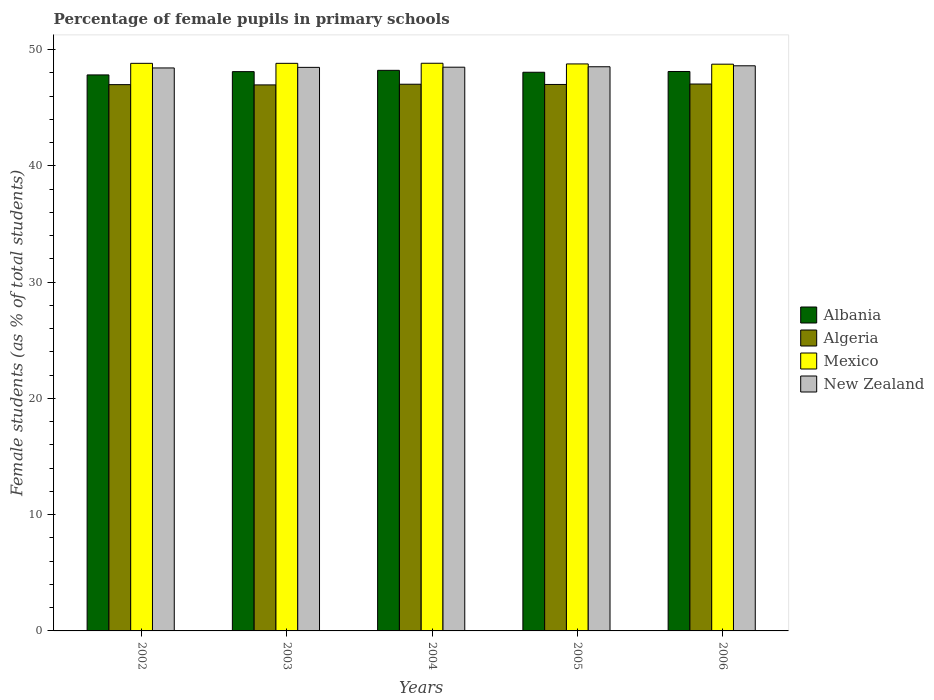How many different coloured bars are there?
Offer a terse response. 4. How many groups of bars are there?
Your answer should be compact. 5. Are the number of bars per tick equal to the number of legend labels?
Offer a very short reply. Yes. How many bars are there on the 4th tick from the left?
Provide a succinct answer. 4. How many bars are there on the 1st tick from the right?
Your answer should be compact. 4. What is the percentage of female pupils in primary schools in Mexico in 2004?
Your answer should be compact. 48.82. Across all years, what is the maximum percentage of female pupils in primary schools in Mexico?
Offer a terse response. 48.82. Across all years, what is the minimum percentage of female pupils in primary schools in New Zealand?
Provide a succinct answer. 48.42. In which year was the percentage of female pupils in primary schools in Algeria maximum?
Keep it short and to the point. 2006. What is the total percentage of female pupils in primary schools in Mexico in the graph?
Offer a very short reply. 243.96. What is the difference between the percentage of female pupils in primary schools in Albania in 2002 and that in 2004?
Ensure brevity in your answer.  -0.39. What is the difference between the percentage of female pupils in primary schools in Mexico in 2005 and the percentage of female pupils in primary schools in New Zealand in 2003?
Provide a short and direct response. 0.3. What is the average percentage of female pupils in primary schools in New Zealand per year?
Your response must be concise. 48.5. In the year 2006, what is the difference between the percentage of female pupils in primary schools in Mexico and percentage of female pupils in primary schools in New Zealand?
Your answer should be very brief. 0.14. What is the ratio of the percentage of female pupils in primary schools in Albania in 2002 to that in 2003?
Provide a succinct answer. 0.99. Is the difference between the percentage of female pupils in primary schools in Mexico in 2002 and 2003 greater than the difference between the percentage of female pupils in primary schools in New Zealand in 2002 and 2003?
Your answer should be very brief. Yes. What is the difference between the highest and the second highest percentage of female pupils in primary schools in Algeria?
Offer a very short reply. 0.02. What is the difference between the highest and the lowest percentage of female pupils in primary schools in Algeria?
Your response must be concise. 0.08. What does the 1st bar from the left in 2005 represents?
Keep it short and to the point. Albania. How many bars are there?
Give a very brief answer. 20. Are the values on the major ticks of Y-axis written in scientific E-notation?
Ensure brevity in your answer.  No. Does the graph contain grids?
Offer a very short reply. No. Where does the legend appear in the graph?
Give a very brief answer. Center right. How many legend labels are there?
Make the answer very short. 4. How are the legend labels stacked?
Provide a short and direct response. Vertical. What is the title of the graph?
Your answer should be compact. Percentage of female pupils in primary schools. What is the label or title of the X-axis?
Offer a very short reply. Years. What is the label or title of the Y-axis?
Keep it short and to the point. Female students (as % of total students). What is the Female students (as % of total students) in Albania in 2002?
Give a very brief answer. 47.82. What is the Female students (as % of total students) in Algeria in 2002?
Your answer should be very brief. 46.98. What is the Female students (as % of total students) of Mexico in 2002?
Make the answer very short. 48.81. What is the Female students (as % of total students) in New Zealand in 2002?
Provide a short and direct response. 48.42. What is the Female students (as % of total students) of Albania in 2003?
Your answer should be very brief. 48.1. What is the Female students (as % of total students) of Algeria in 2003?
Keep it short and to the point. 46.96. What is the Female students (as % of total students) of Mexico in 2003?
Provide a succinct answer. 48.82. What is the Female students (as % of total students) of New Zealand in 2003?
Keep it short and to the point. 48.47. What is the Female students (as % of total students) in Albania in 2004?
Provide a short and direct response. 48.21. What is the Female students (as % of total students) in Algeria in 2004?
Provide a succinct answer. 47.02. What is the Female students (as % of total students) of Mexico in 2004?
Ensure brevity in your answer.  48.82. What is the Female students (as % of total students) in New Zealand in 2004?
Offer a very short reply. 48.48. What is the Female students (as % of total students) in Albania in 2005?
Keep it short and to the point. 48.05. What is the Female students (as % of total students) in Algeria in 2005?
Your answer should be very brief. 47. What is the Female students (as % of total students) of Mexico in 2005?
Your answer should be compact. 48.76. What is the Female students (as % of total students) in New Zealand in 2005?
Your answer should be compact. 48.52. What is the Female students (as % of total students) in Albania in 2006?
Your response must be concise. 48.11. What is the Female students (as % of total students) in Algeria in 2006?
Ensure brevity in your answer.  47.04. What is the Female students (as % of total students) of Mexico in 2006?
Your response must be concise. 48.74. What is the Female students (as % of total students) of New Zealand in 2006?
Give a very brief answer. 48.6. Across all years, what is the maximum Female students (as % of total students) in Albania?
Your answer should be compact. 48.21. Across all years, what is the maximum Female students (as % of total students) in Algeria?
Provide a short and direct response. 47.04. Across all years, what is the maximum Female students (as % of total students) in Mexico?
Your answer should be compact. 48.82. Across all years, what is the maximum Female students (as % of total students) of New Zealand?
Offer a very short reply. 48.6. Across all years, what is the minimum Female students (as % of total students) of Albania?
Give a very brief answer. 47.82. Across all years, what is the minimum Female students (as % of total students) in Algeria?
Make the answer very short. 46.96. Across all years, what is the minimum Female students (as % of total students) in Mexico?
Your answer should be compact. 48.74. Across all years, what is the minimum Female students (as % of total students) of New Zealand?
Ensure brevity in your answer.  48.42. What is the total Female students (as % of total students) in Albania in the graph?
Ensure brevity in your answer.  240.29. What is the total Female students (as % of total students) of Algeria in the graph?
Give a very brief answer. 234.99. What is the total Female students (as % of total students) in Mexico in the graph?
Offer a very short reply. 243.96. What is the total Female students (as % of total students) of New Zealand in the graph?
Offer a very short reply. 242.49. What is the difference between the Female students (as % of total students) of Albania in 2002 and that in 2003?
Give a very brief answer. -0.28. What is the difference between the Female students (as % of total students) of Algeria in 2002 and that in 2003?
Give a very brief answer. 0.02. What is the difference between the Female students (as % of total students) in Mexico in 2002 and that in 2003?
Give a very brief answer. -0. What is the difference between the Female students (as % of total students) in New Zealand in 2002 and that in 2003?
Make the answer very short. -0.05. What is the difference between the Female students (as % of total students) of Albania in 2002 and that in 2004?
Your answer should be compact. -0.39. What is the difference between the Female students (as % of total students) of Algeria in 2002 and that in 2004?
Give a very brief answer. -0.04. What is the difference between the Female students (as % of total students) in Mexico in 2002 and that in 2004?
Keep it short and to the point. -0.01. What is the difference between the Female students (as % of total students) of New Zealand in 2002 and that in 2004?
Ensure brevity in your answer.  -0.06. What is the difference between the Female students (as % of total students) of Albania in 2002 and that in 2005?
Ensure brevity in your answer.  -0.23. What is the difference between the Female students (as % of total students) in Algeria in 2002 and that in 2005?
Offer a terse response. -0.01. What is the difference between the Female students (as % of total students) in Mexico in 2002 and that in 2005?
Provide a succinct answer. 0.05. What is the difference between the Female students (as % of total students) in New Zealand in 2002 and that in 2005?
Give a very brief answer. -0.1. What is the difference between the Female students (as % of total students) of Albania in 2002 and that in 2006?
Your response must be concise. -0.29. What is the difference between the Female students (as % of total students) of Algeria in 2002 and that in 2006?
Offer a terse response. -0.05. What is the difference between the Female students (as % of total students) in Mexico in 2002 and that in 2006?
Provide a short and direct response. 0.07. What is the difference between the Female students (as % of total students) in New Zealand in 2002 and that in 2006?
Make the answer very short. -0.19. What is the difference between the Female students (as % of total students) of Albania in 2003 and that in 2004?
Provide a succinct answer. -0.11. What is the difference between the Female students (as % of total students) in Algeria in 2003 and that in 2004?
Your response must be concise. -0.06. What is the difference between the Female students (as % of total students) in Mexico in 2003 and that in 2004?
Give a very brief answer. -0.01. What is the difference between the Female students (as % of total students) in New Zealand in 2003 and that in 2004?
Your answer should be very brief. -0.01. What is the difference between the Female students (as % of total students) in Albania in 2003 and that in 2005?
Provide a succinct answer. 0.05. What is the difference between the Female students (as % of total students) of Algeria in 2003 and that in 2005?
Offer a very short reply. -0.04. What is the difference between the Female students (as % of total students) in Mexico in 2003 and that in 2005?
Offer a terse response. 0.05. What is the difference between the Female students (as % of total students) of New Zealand in 2003 and that in 2005?
Provide a short and direct response. -0.05. What is the difference between the Female students (as % of total students) of Albania in 2003 and that in 2006?
Keep it short and to the point. -0.01. What is the difference between the Female students (as % of total students) of Algeria in 2003 and that in 2006?
Ensure brevity in your answer.  -0.08. What is the difference between the Female students (as % of total students) in Mexico in 2003 and that in 2006?
Offer a terse response. 0.07. What is the difference between the Female students (as % of total students) in New Zealand in 2003 and that in 2006?
Provide a succinct answer. -0.14. What is the difference between the Female students (as % of total students) in Albania in 2004 and that in 2005?
Your answer should be very brief. 0.17. What is the difference between the Female students (as % of total students) of Algeria in 2004 and that in 2005?
Your answer should be very brief. 0.02. What is the difference between the Female students (as % of total students) of Mexico in 2004 and that in 2005?
Your answer should be very brief. 0.06. What is the difference between the Female students (as % of total students) of New Zealand in 2004 and that in 2005?
Make the answer very short. -0.04. What is the difference between the Female students (as % of total students) in Albania in 2004 and that in 2006?
Make the answer very short. 0.1. What is the difference between the Female students (as % of total students) in Algeria in 2004 and that in 2006?
Your answer should be very brief. -0.02. What is the difference between the Female students (as % of total students) in Mexico in 2004 and that in 2006?
Provide a short and direct response. 0.08. What is the difference between the Female students (as % of total students) in New Zealand in 2004 and that in 2006?
Provide a succinct answer. -0.12. What is the difference between the Female students (as % of total students) in Albania in 2005 and that in 2006?
Provide a succinct answer. -0.07. What is the difference between the Female students (as % of total students) in Algeria in 2005 and that in 2006?
Your answer should be very brief. -0.04. What is the difference between the Female students (as % of total students) of Mexico in 2005 and that in 2006?
Your answer should be compact. 0.02. What is the difference between the Female students (as % of total students) of New Zealand in 2005 and that in 2006?
Give a very brief answer. -0.08. What is the difference between the Female students (as % of total students) in Albania in 2002 and the Female students (as % of total students) in Algeria in 2003?
Provide a succinct answer. 0.86. What is the difference between the Female students (as % of total students) of Albania in 2002 and the Female students (as % of total students) of Mexico in 2003?
Provide a succinct answer. -1. What is the difference between the Female students (as % of total students) of Albania in 2002 and the Female students (as % of total students) of New Zealand in 2003?
Ensure brevity in your answer.  -0.65. What is the difference between the Female students (as % of total students) in Algeria in 2002 and the Female students (as % of total students) in Mexico in 2003?
Give a very brief answer. -1.83. What is the difference between the Female students (as % of total students) in Algeria in 2002 and the Female students (as % of total students) in New Zealand in 2003?
Your response must be concise. -1.49. What is the difference between the Female students (as % of total students) of Mexico in 2002 and the Female students (as % of total students) of New Zealand in 2003?
Provide a short and direct response. 0.35. What is the difference between the Female students (as % of total students) of Albania in 2002 and the Female students (as % of total students) of Algeria in 2004?
Give a very brief answer. 0.8. What is the difference between the Female students (as % of total students) of Albania in 2002 and the Female students (as % of total students) of Mexico in 2004?
Make the answer very short. -1. What is the difference between the Female students (as % of total students) of Albania in 2002 and the Female students (as % of total students) of New Zealand in 2004?
Provide a succinct answer. -0.66. What is the difference between the Female students (as % of total students) in Algeria in 2002 and the Female students (as % of total students) in Mexico in 2004?
Ensure brevity in your answer.  -1.84. What is the difference between the Female students (as % of total students) of Algeria in 2002 and the Female students (as % of total students) of New Zealand in 2004?
Provide a short and direct response. -1.5. What is the difference between the Female students (as % of total students) in Mexico in 2002 and the Female students (as % of total students) in New Zealand in 2004?
Your response must be concise. 0.33. What is the difference between the Female students (as % of total students) in Albania in 2002 and the Female students (as % of total students) in Algeria in 2005?
Ensure brevity in your answer.  0.82. What is the difference between the Female students (as % of total students) in Albania in 2002 and the Female students (as % of total students) in Mexico in 2005?
Make the answer very short. -0.94. What is the difference between the Female students (as % of total students) in Albania in 2002 and the Female students (as % of total students) in New Zealand in 2005?
Keep it short and to the point. -0.7. What is the difference between the Female students (as % of total students) of Algeria in 2002 and the Female students (as % of total students) of Mexico in 2005?
Your response must be concise. -1.78. What is the difference between the Female students (as % of total students) in Algeria in 2002 and the Female students (as % of total students) in New Zealand in 2005?
Provide a succinct answer. -1.54. What is the difference between the Female students (as % of total students) in Mexico in 2002 and the Female students (as % of total students) in New Zealand in 2005?
Provide a short and direct response. 0.29. What is the difference between the Female students (as % of total students) in Albania in 2002 and the Female students (as % of total students) in Algeria in 2006?
Offer a very short reply. 0.78. What is the difference between the Female students (as % of total students) in Albania in 2002 and the Female students (as % of total students) in Mexico in 2006?
Your response must be concise. -0.92. What is the difference between the Female students (as % of total students) of Albania in 2002 and the Female students (as % of total students) of New Zealand in 2006?
Provide a succinct answer. -0.79. What is the difference between the Female students (as % of total students) of Algeria in 2002 and the Female students (as % of total students) of Mexico in 2006?
Make the answer very short. -1.76. What is the difference between the Female students (as % of total students) in Algeria in 2002 and the Female students (as % of total students) in New Zealand in 2006?
Provide a succinct answer. -1.62. What is the difference between the Female students (as % of total students) of Mexico in 2002 and the Female students (as % of total students) of New Zealand in 2006?
Offer a very short reply. 0.21. What is the difference between the Female students (as % of total students) in Albania in 2003 and the Female students (as % of total students) in Algeria in 2004?
Your answer should be very brief. 1.08. What is the difference between the Female students (as % of total students) in Albania in 2003 and the Female students (as % of total students) in Mexico in 2004?
Provide a short and direct response. -0.72. What is the difference between the Female students (as % of total students) of Albania in 2003 and the Female students (as % of total students) of New Zealand in 2004?
Provide a succinct answer. -0.38. What is the difference between the Female students (as % of total students) of Algeria in 2003 and the Female students (as % of total students) of Mexico in 2004?
Your answer should be compact. -1.86. What is the difference between the Female students (as % of total students) in Algeria in 2003 and the Female students (as % of total students) in New Zealand in 2004?
Provide a short and direct response. -1.52. What is the difference between the Female students (as % of total students) of Mexico in 2003 and the Female students (as % of total students) of New Zealand in 2004?
Your answer should be compact. 0.33. What is the difference between the Female students (as % of total students) in Albania in 2003 and the Female students (as % of total students) in Algeria in 2005?
Give a very brief answer. 1.1. What is the difference between the Female students (as % of total students) of Albania in 2003 and the Female students (as % of total students) of Mexico in 2005?
Ensure brevity in your answer.  -0.66. What is the difference between the Female students (as % of total students) of Albania in 2003 and the Female students (as % of total students) of New Zealand in 2005?
Your response must be concise. -0.42. What is the difference between the Female students (as % of total students) of Algeria in 2003 and the Female students (as % of total students) of Mexico in 2005?
Your answer should be very brief. -1.8. What is the difference between the Female students (as % of total students) of Algeria in 2003 and the Female students (as % of total students) of New Zealand in 2005?
Provide a short and direct response. -1.56. What is the difference between the Female students (as % of total students) in Mexico in 2003 and the Female students (as % of total students) in New Zealand in 2005?
Your answer should be compact. 0.3. What is the difference between the Female students (as % of total students) in Albania in 2003 and the Female students (as % of total students) in Algeria in 2006?
Give a very brief answer. 1.07. What is the difference between the Female students (as % of total students) of Albania in 2003 and the Female students (as % of total students) of Mexico in 2006?
Your answer should be compact. -0.64. What is the difference between the Female students (as % of total students) of Albania in 2003 and the Female students (as % of total students) of New Zealand in 2006?
Provide a succinct answer. -0.5. What is the difference between the Female students (as % of total students) in Algeria in 2003 and the Female students (as % of total students) in Mexico in 2006?
Provide a short and direct response. -1.78. What is the difference between the Female students (as % of total students) in Algeria in 2003 and the Female students (as % of total students) in New Zealand in 2006?
Your answer should be very brief. -1.64. What is the difference between the Female students (as % of total students) in Mexico in 2003 and the Female students (as % of total students) in New Zealand in 2006?
Provide a succinct answer. 0.21. What is the difference between the Female students (as % of total students) of Albania in 2004 and the Female students (as % of total students) of Algeria in 2005?
Make the answer very short. 1.22. What is the difference between the Female students (as % of total students) in Albania in 2004 and the Female students (as % of total students) in Mexico in 2005?
Provide a succinct answer. -0.55. What is the difference between the Female students (as % of total students) in Albania in 2004 and the Female students (as % of total students) in New Zealand in 2005?
Provide a short and direct response. -0.31. What is the difference between the Female students (as % of total students) in Algeria in 2004 and the Female students (as % of total students) in Mexico in 2005?
Provide a succinct answer. -1.75. What is the difference between the Female students (as % of total students) of Algeria in 2004 and the Female students (as % of total students) of New Zealand in 2005?
Your answer should be very brief. -1.5. What is the difference between the Female students (as % of total students) in Mexico in 2004 and the Female students (as % of total students) in New Zealand in 2005?
Give a very brief answer. 0.3. What is the difference between the Female students (as % of total students) in Albania in 2004 and the Female students (as % of total students) in Algeria in 2006?
Your answer should be compact. 1.18. What is the difference between the Female students (as % of total students) of Albania in 2004 and the Female students (as % of total students) of Mexico in 2006?
Keep it short and to the point. -0.53. What is the difference between the Female students (as % of total students) in Albania in 2004 and the Female students (as % of total students) in New Zealand in 2006?
Provide a succinct answer. -0.39. What is the difference between the Female students (as % of total students) in Algeria in 2004 and the Female students (as % of total students) in Mexico in 2006?
Give a very brief answer. -1.72. What is the difference between the Female students (as % of total students) in Algeria in 2004 and the Female students (as % of total students) in New Zealand in 2006?
Provide a short and direct response. -1.58. What is the difference between the Female students (as % of total students) of Mexico in 2004 and the Female students (as % of total students) of New Zealand in 2006?
Ensure brevity in your answer.  0.22. What is the difference between the Female students (as % of total students) of Albania in 2005 and the Female students (as % of total students) of Algeria in 2006?
Provide a short and direct response. 1.01. What is the difference between the Female students (as % of total students) in Albania in 2005 and the Female students (as % of total students) in Mexico in 2006?
Ensure brevity in your answer.  -0.69. What is the difference between the Female students (as % of total students) in Albania in 2005 and the Female students (as % of total students) in New Zealand in 2006?
Your response must be concise. -0.56. What is the difference between the Female students (as % of total students) in Algeria in 2005 and the Female students (as % of total students) in Mexico in 2006?
Keep it short and to the point. -1.74. What is the difference between the Female students (as % of total students) of Algeria in 2005 and the Female students (as % of total students) of New Zealand in 2006?
Provide a succinct answer. -1.61. What is the difference between the Female students (as % of total students) of Mexico in 2005 and the Female students (as % of total students) of New Zealand in 2006?
Provide a succinct answer. 0.16. What is the average Female students (as % of total students) in Albania per year?
Offer a very short reply. 48.06. What is the average Female students (as % of total students) in Algeria per year?
Make the answer very short. 47. What is the average Female students (as % of total students) in Mexico per year?
Provide a short and direct response. 48.79. What is the average Female students (as % of total students) of New Zealand per year?
Provide a short and direct response. 48.5. In the year 2002, what is the difference between the Female students (as % of total students) in Albania and Female students (as % of total students) in Algeria?
Ensure brevity in your answer.  0.84. In the year 2002, what is the difference between the Female students (as % of total students) in Albania and Female students (as % of total students) in Mexico?
Provide a short and direct response. -1. In the year 2002, what is the difference between the Female students (as % of total students) in Albania and Female students (as % of total students) in New Zealand?
Your answer should be compact. -0.6. In the year 2002, what is the difference between the Female students (as % of total students) in Algeria and Female students (as % of total students) in Mexico?
Provide a short and direct response. -1.83. In the year 2002, what is the difference between the Female students (as % of total students) in Algeria and Female students (as % of total students) in New Zealand?
Your response must be concise. -1.44. In the year 2002, what is the difference between the Female students (as % of total students) of Mexico and Female students (as % of total students) of New Zealand?
Your response must be concise. 0.4. In the year 2003, what is the difference between the Female students (as % of total students) of Albania and Female students (as % of total students) of Algeria?
Keep it short and to the point. 1.14. In the year 2003, what is the difference between the Female students (as % of total students) in Albania and Female students (as % of total students) in Mexico?
Offer a terse response. -0.71. In the year 2003, what is the difference between the Female students (as % of total students) in Albania and Female students (as % of total students) in New Zealand?
Your response must be concise. -0.37. In the year 2003, what is the difference between the Female students (as % of total students) in Algeria and Female students (as % of total students) in Mexico?
Make the answer very short. -1.86. In the year 2003, what is the difference between the Female students (as % of total students) in Algeria and Female students (as % of total students) in New Zealand?
Provide a short and direct response. -1.51. In the year 2003, what is the difference between the Female students (as % of total students) in Mexico and Female students (as % of total students) in New Zealand?
Keep it short and to the point. 0.35. In the year 2004, what is the difference between the Female students (as % of total students) in Albania and Female students (as % of total students) in Algeria?
Keep it short and to the point. 1.19. In the year 2004, what is the difference between the Female students (as % of total students) in Albania and Female students (as % of total students) in Mexico?
Offer a very short reply. -0.61. In the year 2004, what is the difference between the Female students (as % of total students) of Albania and Female students (as % of total students) of New Zealand?
Your answer should be compact. -0.27. In the year 2004, what is the difference between the Female students (as % of total students) of Algeria and Female students (as % of total students) of Mexico?
Offer a very short reply. -1.8. In the year 2004, what is the difference between the Female students (as % of total students) of Algeria and Female students (as % of total students) of New Zealand?
Provide a succinct answer. -1.46. In the year 2004, what is the difference between the Female students (as % of total students) in Mexico and Female students (as % of total students) in New Zealand?
Offer a terse response. 0.34. In the year 2005, what is the difference between the Female students (as % of total students) of Albania and Female students (as % of total students) of Algeria?
Your response must be concise. 1.05. In the year 2005, what is the difference between the Female students (as % of total students) in Albania and Female students (as % of total students) in Mexico?
Make the answer very short. -0.72. In the year 2005, what is the difference between the Female students (as % of total students) of Albania and Female students (as % of total students) of New Zealand?
Provide a short and direct response. -0.47. In the year 2005, what is the difference between the Female students (as % of total students) in Algeria and Female students (as % of total students) in Mexico?
Ensure brevity in your answer.  -1.77. In the year 2005, what is the difference between the Female students (as % of total students) in Algeria and Female students (as % of total students) in New Zealand?
Keep it short and to the point. -1.52. In the year 2005, what is the difference between the Female students (as % of total students) of Mexico and Female students (as % of total students) of New Zealand?
Ensure brevity in your answer.  0.24. In the year 2006, what is the difference between the Female students (as % of total students) in Albania and Female students (as % of total students) in Algeria?
Your answer should be very brief. 1.08. In the year 2006, what is the difference between the Female students (as % of total students) in Albania and Female students (as % of total students) in Mexico?
Provide a short and direct response. -0.63. In the year 2006, what is the difference between the Female students (as % of total students) in Albania and Female students (as % of total students) in New Zealand?
Offer a terse response. -0.49. In the year 2006, what is the difference between the Female students (as % of total students) in Algeria and Female students (as % of total students) in Mexico?
Ensure brevity in your answer.  -1.71. In the year 2006, what is the difference between the Female students (as % of total students) of Algeria and Female students (as % of total students) of New Zealand?
Offer a very short reply. -1.57. In the year 2006, what is the difference between the Female students (as % of total students) in Mexico and Female students (as % of total students) in New Zealand?
Make the answer very short. 0.14. What is the ratio of the Female students (as % of total students) in Mexico in 2002 to that in 2003?
Make the answer very short. 1. What is the ratio of the Female students (as % of total students) of Albania in 2002 to that in 2004?
Provide a succinct answer. 0.99. What is the ratio of the Female students (as % of total students) in Albania in 2002 to that in 2005?
Your response must be concise. 1. What is the ratio of the Female students (as % of total students) of Algeria in 2002 to that in 2006?
Offer a terse response. 1. What is the ratio of the Female students (as % of total students) of Mexico in 2002 to that in 2006?
Provide a short and direct response. 1. What is the ratio of the Female students (as % of total students) of Algeria in 2003 to that in 2004?
Provide a succinct answer. 1. What is the ratio of the Female students (as % of total students) in Mexico in 2003 to that in 2004?
Ensure brevity in your answer.  1. What is the ratio of the Female students (as % of total students) in Mexico in 2003 to that in 2005?
Your response must be concise. 1. What is the ratio of the Female students (as % of total students) in New Zealand in 2003 to that in 2005?
Make the answer very short. 1. What is the ratio of the Female students (as % of total students) of Albania in 2003 to that in 2006?
Give a very brief answer. 1. What is the ratio of the Female students (as % of total students) of Algeria in 2003 to that in 2006?
Make the answer very short. 1. What is the ratio of the Female students (as % of total students) in Mexico in 2003 to that in 2006?
Make the answer very short. 1. What is the ratio of the Female students (as % of total students) of New Zealand in 2003 to that in 2006?
Keep it short and to the point. 1. What is the ratio of the Female students (as % of total students) in Albania in 2004 to that in 2006?
Your answer should be compact. 1. What is the ratio of the Female students (as % of total students) in New Zealand in 2004 to that in 2006?
Offer a terse response. 1. What is the ratio of the Female students (as % of total students) of Albania in 2005 to that in 2006?
Make the answer very short. 1. What is the ratio of the Female students (as % of total students) of New Zealand in 2005 to that in 2006?
Give a very brief answer. 1. What is the difference between the highest and the second highest Female students (as % of total students) in Albania?
Provide a short and direct response. 0.1. What is the difference between the highest and the second highest Female students (as % of total students) of Algeria?
Your answer should be very brief. 0.02. What is the difference between the highest and the second highest Female students (as % of total students) of Mexico?
Offer a very short reply. 0.01. What is the difference between the highest and the second highest Female students (as % of total students) in New Zealand?
Your answer should be compact. 0.08. What is the difference between the highest and the lowest Female students (as % of total students) in Albania?
Offer a very short reply. 0.39. What is the difference between the highest and the lowest Female students (as % of total students) in Algeria?
Your response must be concise. 0.08. What is the difference between the highest and the lowest Female students (as % of total students) in Mexico?
Your answer should be compact. 0.08. What is the difference between the highest and the lowest Female students (as % of total students) of New Zealand?
Your response must be concise. 0.19. 